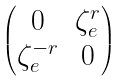Convert formula to latex. <formula><loc_0><loc_0><loc_500><loc_500>\begin{pmatrix} 0 & \zeta _ { e } ^ { r } \\ \zeta _ { e } ^ { - r } & 0 \end{pmatrix}</formula> 